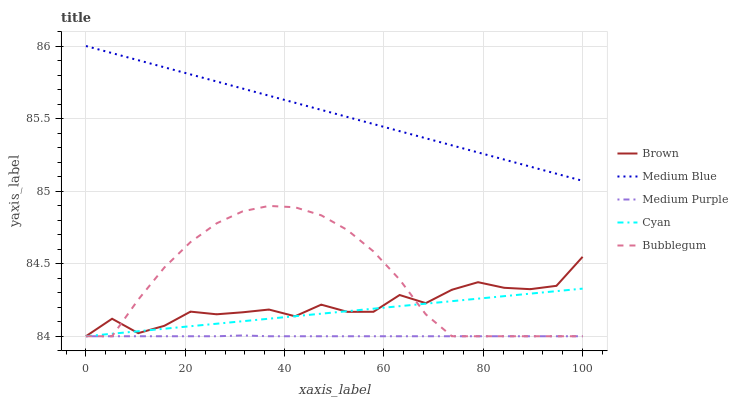Does Medium Purple have the minimum area under the curve?
Answer yes or no. Yes. Does Medium Blue have the maximum area under the curve?
Answer yes or no. Yes. Does Brown have the minimum area under the curve?
Answer yes or no. No. Does Brown have the maximum area under the curve?
Answer yes or no. No. Is Medium Blue the smoothest?
Answer yes or no. Yes. Is Brown the roughest?
Answer yes or no. Yes. Is Brown the smoothest?
Answer yes or no. No. Is Medium Blue the roughest?
Answer yes or no. No. Does Medium Purple have the lowest value?
Answer yes or no. Yes. Does Medium Blue have the lowest value?
Answer yes or no. No. Does Medium Blue have the highest value?
Answer yes or no. Yes. Does Brown have the highest value?
Answer yes or no. No. Is Medium Purple less than Medium Blue?
Answer yes or no. Yes. Is Medium Blue greater than Cyan?
Answer yes or no. Yes. Does Bubblegum intersect Medium Purple?
Answer yes or no. Yes. Is Bubblegum less than Medium Purple?
Answer yes or no. No. Is Bubblegum greater than Medium Purple?
Answer yes or no. No. Does Medium Purple intersect Medium Blue?
Answer yes or no. No. 